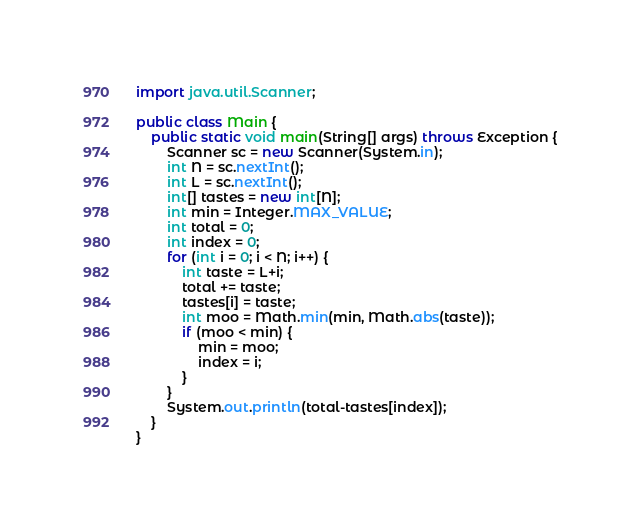<code> <loc_0><loc_0><loc_500><loc_500><_Java_>import java.util.Scanner;

public class Main {
    public static void main(String[] args) throws Exception {
        Scanner sc = new Scanner(System.in);
        int N = sc.nextInt();
        int L = sc.nextInt();
        int[] tastes = new int[N];
        int min = Integer.MAX_VALUE;
        int total = 0;
        int index = 0;
        for (int i = 0; i < N; i++) {
            int taste = L+i;
            total += taste;
            tastes[i] = taste;
            int moo = Math.min(min, Math.abs(taste));
            if (moo < min) {
                min = moo;
                index = i;
            }
        }
        System.out.println(total-tastes[index]);
    }
}</code> 